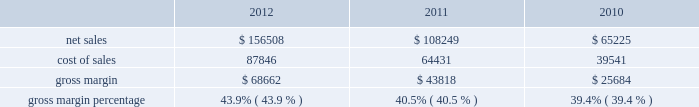$ 43.3 million in 2011 compared to $ 34.1 million in 2010 .
The retail segment represented 13% ( 13 % ) and 15% ( 15 % ) of the company 2019s total net sales in 2011 and 2010 , respectively .
The retail segment 2019s operating income was $ 4.7 billion , $ 3.2 billion , and $ 2.3 billion during 2012 , 2011 , and 2010 respectively .
These year-over-year increases in retail operating income were primarily attributable to higher overall net sales that resulted in significantly higher average revenue per store during the respective years .
Gross margin gross margin for 2012 , 2011 and 2010 are as follows ( in millions , except gross margin percentages ) : .
The gross margin percentage in 2012 was 43.9% ( 43.9 % ) , compared to 40.5% ( 40.5 % ) in 2011 .
This year-over-year increase in gross margin was largely driven by lower commodity and other product costs , a higher mix of iphone sales , and improved leverage on fixed costs from higher net sales .
The increase in gross margin was partially offset by the impact of a stronger u.s .
Dollar .
The gross margin percentage during the first half of 2012 was 45.9% ( 45.9 % ) compared to 41.4% ( 41.4 % ) during the second half of 2012 .
The primary drivers of higher gross margin in the first half of 2012 compared to the second half are a higher mix of iphone sales and improved leverage on fixed costs from higher net sales .
Additionally , gross margin in the second half of 2012 was also affected by the introduction of new products with flat pricing that have higher cost structures and deliver greater value to customers , price reductions on certain existing products , higher transition costs associated with product launches , and continued strengthening of the u.s .
Dollar ; partially offset by lower commodity costs .
The gross margin percentage in 2011 was 40.5% ( 40.5 % ) , compared to 39.4% ( 39.4 % ) in 2010 .
This year-over-year increase in gross margin was largely driven by lower commodity and other product costs .
The company expects to experience decreases in its gross margin percentage in future periods , as compared to levels achieved during 2012 , and the company anticipates gross margin of about 36% ( 36 % ) during the first quarter of 2013 .
Expected future declines in gross margin are largely due to a higher mix of new and innovative products with flat or reduced pricing that have higher cost structures and deliver greater value to customers and anticipated component cost and other cost increases .
Future strengthening of the u.s .
Dollar could further negatively impact gross margin .
The foregoing statements regarding the company 2019s expected gross margin percentage in future periods , including the first quarter of 2013 , are forward-looking and could differ from actual results because of several factors including , but not limited to those set forth above in part i , item 1a of this form 10-k under the heading 201crisk factors 201d and those described in this paragraph .
In general , gross margins and margins on individual products will remain under downward pressure due to a variety of factors , including continued industry wide global product pricing pressures , increased competition , compressed product life cycles , product transitions and potential increases in the cost of components , as well as potential increases in the costs of outside manufacturing services and a potential shift in the company 2019s sales mix towards products with lower gross margins .
In response to competitive pressures , the company expects it will continue to take product pricing actions , which would adversely affect gross margins .
Gross margins could also be affected by the company 2019s ability to manage product quality and warranty costs effectively and to stimulate demand for certain of its products .
Due to the company 2019s significant international operations , financial results can be significantly affected in the short-term by fluctuations in exchange rates. .
What was the percentage change in net sales from 2010 to 2011? 
Computations: ((108249 - 65225) / 65225)
Answer: 0.65962. $ 43.3 million in 2011 compared to $ 34.1 million in 2010 .
The retail segment represented 13% ( 13 % ) and 15% ( 15 % ) of the company 2019s total net sales in 2011 and 2010 , respectively .
The retail segment 2019s operating income was $ 4.7 billion , $ 3.2 billion , and $ 2.3 billion during 2012 , 2011 , and 2010 respectively .
These year-over-year increases in retail operating income were primarily attributable to higher overall net sales that resulted in significantly higher average revenue per store during the respective years .
Gross margin gross margin for 2012 , 2011 and 2010 are as follows ( in millions , except gross margin percentages ) : .
The gross margin percentage in 2012 was 43.9% ( 43.9 % ) , compared to 40.5% ( 40.5 % ) in 2011 .
This year-over-year increase in gross margin was largely driven by lower commodity and other product costs , a higher mix of iphone sales , and improved leverage on fixed costs from higher net sales .
The increase in gross margin was partially offset by the impact of a stronger u.s .
Dollar .
The gross margin percentage during the first half of 2012 was 45.9% ( 45.9 % ) compared to 41.4% ( 41.4 % ) during the second half of 2012 .
The primary drivers of higher gross margin in the first half of 2012 compared to the second half are a higher mix of iphone sales and improved leverage on fixed costs from higher net sales .
Additionally , gross margin in the second half of 2012 was also affected by the introduction of new products with flat pricing that have higher cost structures and deliver greater value to customers , price reductions on certain existing products , higher transition costs associated with product launches , and continued strengthening of the u.s .
Dollar ; partially offset by lower commodity costs .
The gross margin percentage in 2011 was 40.5% ( 40.5 % ) , compared to 39.4% ( 39.4 % ) in 2010 .
This year-over-year increase in gross margin was largely driven by lower commodity and other product costs .
The company expects to experience decreases in its gross margin percentage in future periods , as compared to levels achieved during 2012 , and the company anticipates gross margin of about 36% ( 36 % ) during the first quarter of 2013 .
Expected future declines in gross margin are largely due to a higher mix of new and innovative products with flat or reduced pricing that have higher cost structures and deliver greater value to customers and anticipated component cost and other cost increases .
Future strengthening of the u.s .
Dollar could further negatively impact gross margin .
The foregoing statements regarding the company 2019s expected gross margin percentage in future periods , including the first quarter of 2013 , are forward-looking and could differ from actual results because of several factors including , but not limited to those set forth above in part i , item 1a of this form 10-k under the heading 201crisk factors 201d and those described in this paragraph .
In general , gross margins and margins on individual products will remain under downward pressure due to a variety of factors , including continued industry wide global product pricing pressures , increased competition , compressed product life cycles , product transitions and potential increases in the cost of components , as well as potential increases in the costs of outside manufacturing services and a potential shift in the company 2019s sales mix towards products with lower gross margins .
In response to competitive pressures , the company expects it will continue to take product pricing actions , which would adversely affect gross margins .
Gross margins could also be affected by the company 2019s ability to manage product quality and warranty costs effectively and to stimulate demand for certain of its products .
Due to the company 2019s significant international operations , financial results can be significantly affected in the short-term by fluctuations in exchange rates. .
What was the increase in gross margin percentage between 2011 and 2012? 
Computations: (40.5 - 39.4)
Answer: 1.1. 